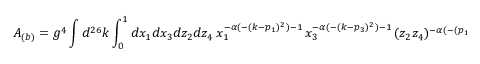<formula> <loc_0><loc_0><loc_500><loc_500>A _ { ( b ) } = g ^ { 4 } \int d ^ { 2 6 } k \int _ { 0 } ^ { 1 } d x _ { 1 } d x _ { 3 } d z _ { 2 } d z _ { 4 } x _ { 1 } ^ { - \alpha ( - ( k - p _ { 1 } ) ^ { 2 } ) - 1 } \, x _ { 3 } ^ { - \alpha ( - ( k - p _ { 3 } ) ^ { 2 } ) - 1 } \, ( z _ { 2 } z _ { 4 } ) ^ { - \alpha ( - ( p _ { 1 } - p _ { 3 } ) ^ { 2 } ) - 1 } .</formula> 